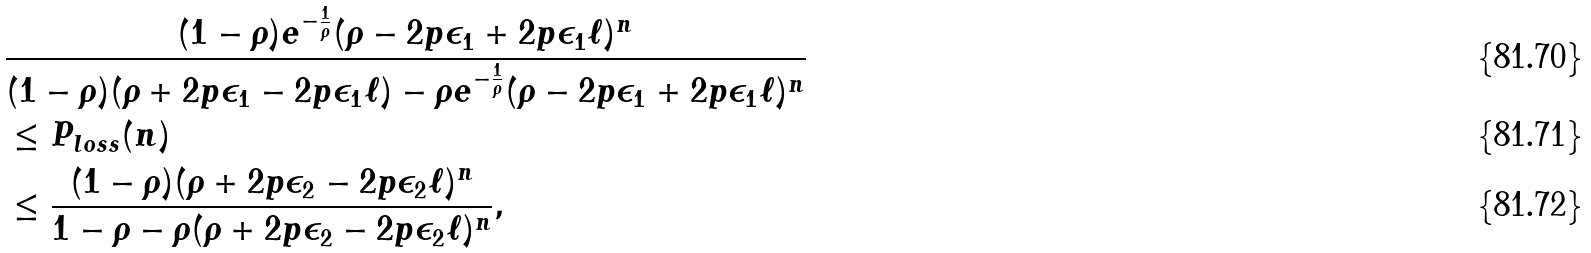<formula> <loc_0><loc_0><loc_500><loc_500>& \frac { ( 1 - \rho ) e ^ { - \frac { 1 } { \rho } } ( \rho - 2 p \epsilon _ { 1 } + 2 p \epsilon _ { 1 } \ell ) ^ { n } } { ( 1 - \rho ) ( \rho + 2 p \epsilon _ { 1 } - 2 p \epsilon _ { 1 } \ell ) - \rho e ^ { - \frac { 1 } { \rho } } ( \rho - 2 p \epsilon _ { 1 } + 2 p \epsilon _ { 1 } \ell ) ^ { n } } \\ & \leq P _ { l o s s } ( n ) \\ & \leq \frac { ( 1 - \rho ) ( \rho + 2 p \epsilon _ { 2 } - 2 p \epsilon _ { 2 } \ell ) ^ { n } } { 1 - \rho - \rho ( \rho + 2 p \epsilon _ { 2 } - 2 p \epsilon _ { 2 } \ell ) ^ { n } } ,</formula> 